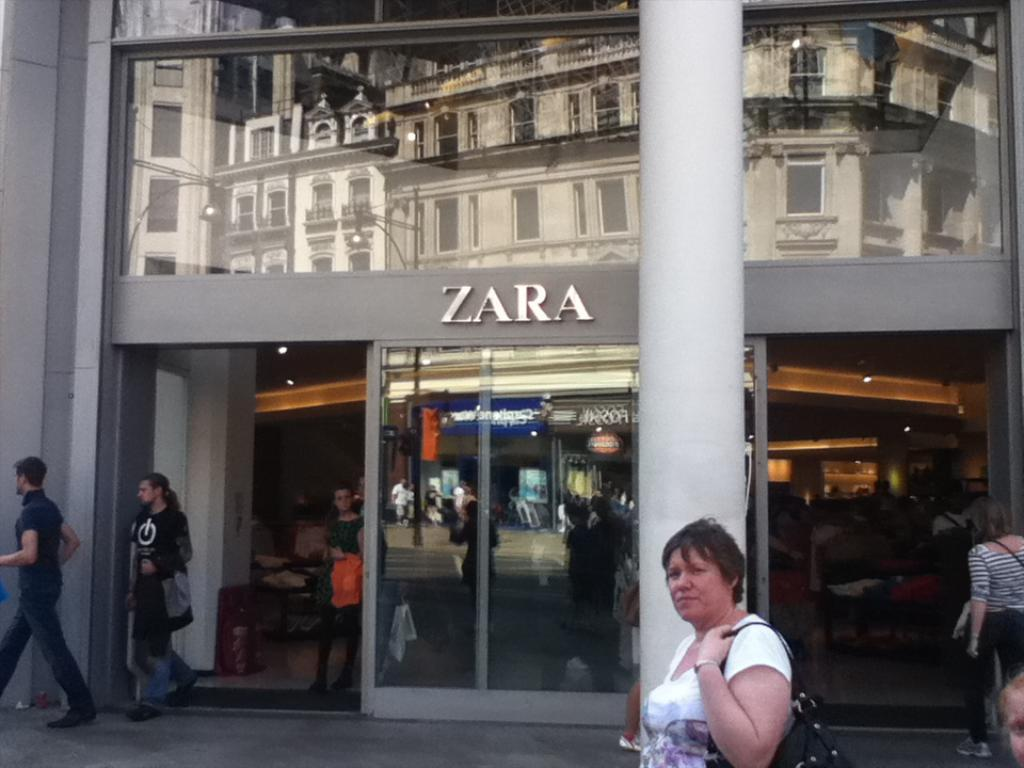What is happening in the image? There is a group of people standing in the image. What can be seen in the background of the image? There are buildings visible in the image. What might be providing illumination in the image? There are lights present in the image. What book is the person reading in the image? There is no person reading a book in the image. What type of needle is being used by the person in the image? There is no person using a needle in the image. 